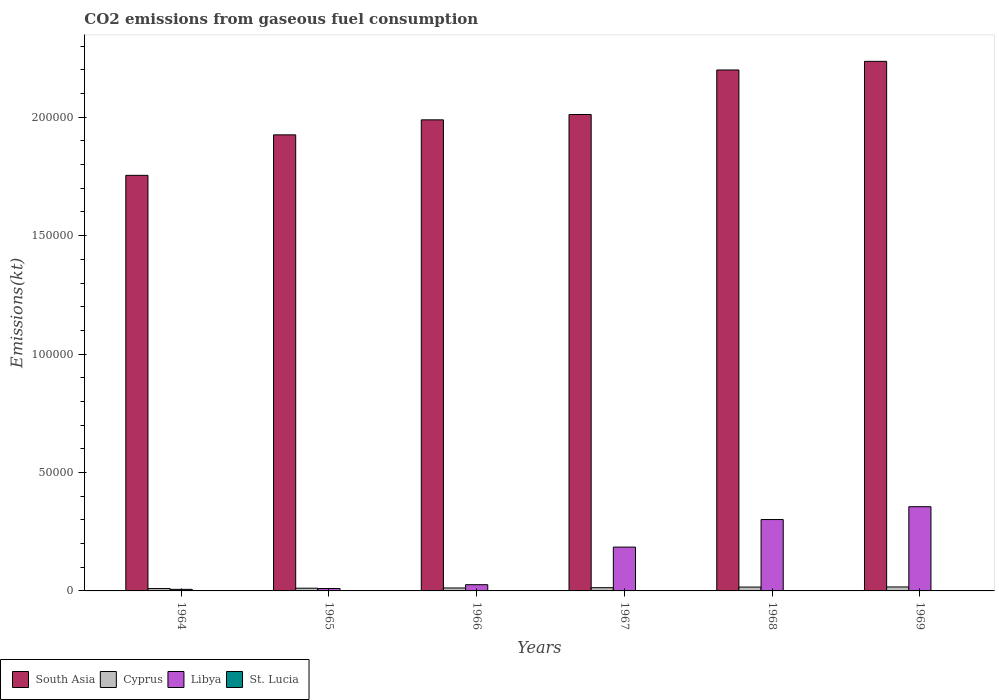How many different coloured bars are there?
Provide a succinct answer. 4. What is the label of the 2nd group of bars from the left?
Provide a short and direct response. 1965. What is the amount of CO2 emitted in Cyprus in 1968?
Keep it short and to the point. 1624.48. Across all years, what is the maximum amount of CO2 emitted in St. Lucia?
Make the answer very short. 62.34. Across all years, what is the minimum amount of CO2 emitted in Libya?
Your response must be concise. 663.73. In which year was the amount of CO2 emitted in St. Lucia maximum?
Offer a very short reply. 1969. In which year was the amount of CO2 emitted in South Asia minimum?
Provide a succinct answer. 1964. What is the total amount of CO2 emitted in Libya in the graph?
Provide a succinct answer. 8.85e+04. What is the difference between the amount of CO2 emitted in Libya in 1966 and that in 1968?
Your answer should be very brief. -2.75e+04. What is the difference between the amount of CO2 emitted in South Asia in 1968 and the amount of CO2 emitted in St. Lucia in 1969?
Your answer should be compact. 2.20e+05. What is the average amount of CO2 emitted in Cyprus per year?
Give a very brief answer. 1342.73. In the year 1969, what is the difference between the amount of CO2 emitted in Cyprus and amount of CO2 emitted in South Asia?
Give a very brief answer. -2.22e+05. What is the ratio of the amount of CO2 emitted in South Asia in 1965 to that in 1968?
Provide a succinct answer. 0.88. Is the difference between the amount of CO2 emitted in Cyprus in 1965 and 1967 greater than the difference between the amount of CO2 emitted in South Asia in 1965 and 1967?
Offer a very short reply. Yes. What is the difference between the highest and the second highest amount of CO2 emitted in Libya?
Give a very brief answer. 5412.49. What is the difference between the highest and the lowest amount of CO2 emitted in Libya?
Make the answer very short. 3.49e+04. What does the 3rd bar from the left in 1968 represents?
Ensure brevity in your answer.  Libya. What does the 2nd bar from the right in 1968 represents?
Your answer should be compact. Libya. How many years are there in the graph?
Make the answer very short. 6. Does the graph contain any zero values?
Your answer should be compact. No. Where does the legend appear in the graph?
Provide a succinct answer. Bottom left. How are the legend labels stacked?
Ensure brevity in your answer.  Horizontal. What is the title of the graph?
Ensure brevity in your answer.  CO2 emissions from gaseous fuel consumption. Does "Croatia" appear as one of the legend labels in the graph?
Your answer should be compact. No. What is the label or title of the X-axis?
Offer a very short reply. Years. What is the label or title of the Y-axis?
Your answer should be compact. Emissions(kt). What is the Emissions(kt) of South Asia in 1964?
Provide a short and direct response. 1.75e+05. What is the Emissions(kt) of Cyprus in 1964?
Make the answer very short. 1001.09. What is the Emissions(kt) in Libya in 1964?
Your answer should be compact. 663.73. What is the Emissions(kt) of St. Lucia in 1964?
Offer a very short reply. 22. What is the Emissions(kt) in South Asia in 1965?
Your answer should be very brief. 1.93e+05. What is the Emissions(kt) in Cyprus in 1965?
Offer a very short reply. 1151.44. What is the Emissions(kt) in Libya in 1965?
Make the answer very short. 1015.76. What is the Emissions(kt) of St. Lucia in 1965?
Provide a succinct answer. 25.67. What is the Emissions(kt) in South Asia in 1966?
Your answer should be compact. 1.99e+05. What is the Emissions(kt) of Cyprus in 1966?
Offer a very short reply. 1243.11. What is the Emissions(kt) of Libya in 1966?
Offer a terse response. 2629.24. What is the Emissions(kt) of St. Lucia in 1966?
Offer a terse response. 29.34. What is the Emissions(kt) of South Asia in 1967?
Keep it short and to the point. 2.01e+05. What is the Emissions(kt) in Cyprus in 1967?
Your answer should be compact. 1364.12. What is the Emissions(kt) of Libya in 1967?
Your answer should be compact. 1.85e+04. What is the Emissions(kt) in St. Lucia in 1967?
Keep it short and to the point. 33. What is the Emissions(kt) of South Asia in 1968?
Offer a terse response. 2.20e+05. What is the Emissions(kt) in Cyprus in 1968?
Provide a short and direct response. 1624.48. What is the Emissions(kt) in Libya in 1968?
Ensure brevity in your answer.  3.01e+04. What is the Emissions(kt) in St. Lucia in 1968?
Keep it short and to the point. 36.67. What is the Emissions(kt) in South Asia in 1969?
Your answer should be very brief. 2.24e+05. What is the Emissions(kt) in Cyprus in 1969?
Offer a very short reply. 1672.15. What is the Emissions(kt) in Libya in 1969?
Offer a very short reply. 3.56e+04. What is the Emissions(kt) in St. Lucia in 1969?
Provide a short and direct response. 62.34. Across all years, what is the maximum Emissions(kt) in South Asia?
Give a very brief answer. 2.24e+05. Across all years, what is the maximum Emissions(kt) in Cyprus?
Provide a succinct answer. 1672.15. Across all years, what is the maximum Emissions(kt) of Libya?
Offer a very short reply. 3.56e+04. Across all years, what is the maximum Emissions(kt) of St. Lucia?
Make the answer very short. 62.34. Across all years, what is the minimum Emissions(kt) in South Asia?
Offer a very short reply. 1.75e+05. Across all years, what is the minimum Emissions(kt) in Cyprus?
Offer a very short reply. 1001.09. Across all years, what is the minimum Emissions(kt) of Libya?
Offer a terse response. 663.73. Across all years, what is the minimum Emissions(kt) in St. Lucia?
Your answer should be very brief. 22. What is the total Emissions(kt) in South Asia in the graph?
Your answer should be compact. 1.21e+06. What is the total Emissions(kt) in Cyprus in the graph?
Provide a short and direct response. 8056.4. What is the total Emissions(kt) in Libya in the graph?
Your response must be concise. 8.85e+04. What is the total Emissions(kt) in St. Lucia in the graph?
Provide a short and direct response. 209.02. What is the difference between the Emissions(kt) of South Asia in 1964 and that in 1965?
Give a very brief answer. -1.71e+04. What is the difference between the Emissions(kt) in Cyprus in 1964 and that in 1965?
Keep it short and to the point. -150.35. What is the difference between the Emissions(kt) of Libya in 1964 and that in 1965?
Make the answer very short. -352.03. What is the difference between the Emissions(kt) of St. Lucia in 1964 and that in 1965?
Give a very brief answer. -3.67. What is the difference between the Emissions(kt) of South Asia in 1964 and that in 1966?
Give a very brief answer. -2.34e+04. What is the difference between the Emissions(kt) of Cyprus in 1964 and that in 1966?
Your response must be concise. -242.02. What is the difference between the Emissions(kt) of Libya in 1964 and that in 1966?
Keep it short and to the point. -1965.51. What is the difference between the Emissions(kt) of St. Lucia in 1964 and that in 1966?
Your answer should be very brief. -7.33. What is the difference between the Emissions(kt) of South Asia in 1964 and that in 1967?
Provide a succinct answer. -2.57e+04. What is the difference between the Emissions(kt) in Cyprus in 1964 and that in 1967?
Your answer should be very brief. -363.03. What is the difference between the Emissions(kt) in Libya in 1964 and that in 1967?
Your response must be concise. -1.78e+04. What is the difference between the Emissions(kt) of St. Lucia in 1964 and that in 1967?
Offer a very short reply. -11. What is the difference between the Emissions(kt) of South Asia in 1964 and that in 1968?
Provide a short and direct response. -4.45e+04. What is the difference between the Emissions(kt) in Cyprus in 1964 and that in 1968?
Offer a very short reply. -623.39. What is the difference between the Emissions(kt) of Libya in 1964 and that in 1968?
Offer a terse response. -2.95e+04. What is the difference between the Emissions(kt) in St. Lucia in 1964 and that in 1968?
Offer a very short reply. -14.67. What is the difference between the Emissions(kt) of South Asia in 1964 and that in 1969?
Provide a succinct answer. -4.81e+04. What is the difference between the Emissions(kt) in Cyprus in 1964 and that in 1969?
Ensure brevity in your answer.  -671.06. What is the difference between the Emissions(kt) of Libya in 1964 and that in 1969?
Make the answer very short. -3.49e+04. What is the difference between the Emissions(kt) of St. Lucia in 1964 and that in 1969?
Offer a very short reply. -40.34. What is the difference between the Emissions(kt) of South Asia in 1965 and that in 1966?
Ensure brevity in your answer.  -6335.61. What is the difference between the Emissions(kt) of Cyprus in 1965 and that in 1966?
Provide a succinct answer. -91.67. What is the difference between the Emissions(kt) of Libya in 1965 and that in 1966?
Your response must be concise. -1613.48. What is the difference between the Emissions(kt) of St. Lucia in 1965 and that in 1966?
Provide a short and direct response. -3.67. What is the difference between the Emissions(kt) in South Asia in 1965 and that in 1967?
Your answer should be compact. -8586.38. What is the difference between the Emissions(kt) in Cyprus in 1965 and that in 1967?
Your answer should be compact. -212.69. What is the difference between the Emissions(kt) in Libya in 1965 and that in 1967?
Offer a very short reply. -1.75e+04. What is the difference between the Emissions(kt) in St. Lucia in 1965 and that in 1967?
Provide a short and direct response. -7.33. What is the difference between the Emissions(kt) in South Asia in 1965 and that in 1968?
Provide a short and direct response. -2.74e+04. What is the difference between the Emissions(kt) in Cyprus in 1965 and that in 1968?
Your response must be concise. -473.04. What is the difference between the Emissions(kt) in Libya in 1965 and that in 1968?
Your answer should be compact. -2.91e+04. What is the difference between the Emissions(kt) in St. Lucia in 1965 and that in 1968?
Ensure brevity in your answer.  -11. What is the difference between the Emissions(kt) of South Asia in 1965 and that in 1969?
Ensure brevity in your answer.  -3.10e+04. What is the difference between the Emissions(kt) of Cyprus in 1965 and that in 1969?
Provide a succinct answer. -520.71. What is the difference between the Emissions(kt) in Libya in 1965 and that in 1969?
Your answer should be very brief. -3.45e+04. What is the difference between the Emissions(kt) in St. Lucia in 1965 and that in 1969?
Give a very brief answer. -36.67. What is the difference between the Emissions(kt) in South Asia in 1966 and that in 1967?
Offer a very short reply. -2250.76. What is the difference between the Emissions(kt) of Cyprus in 1966 and that in 1967?
Make the answer very short. -121.01. What is the difference between the Emissions(kt) in Libya in 1966 and that in 1967?
Offer a terse response. -1.59e+04. What is the difference between the Emissions(kt) of St. Lucia in 1966 and that in 1967?
Your response must be concise. -3.67. What is the difference between the Emissions(kt) in South Asia in 1966 and that in 1968?
Your answer should be compact. -2.11e+04. What is the difference between the Emissions(kt) of Cyprus in 1966 and that in 1968?
Offer a terse response. -381.37. What is the difference between the Emissions(kt) of Libya in 1966 and that in 1968?
Offer a terse response. -2.75e+04. What is the difference between the Emissions(kt) of St. Lucia in 1966 and that in 1968?
Make the answer very short. -7.33. What is the difference between the Emissions(kt) in South Asia in 1966 and that in 1969?
Provide a succinct answer. -2.47e+04. What is the difference between the Emissions(kt) in Cyprus in 1966 and that in 1969?
Your answer should be compact. -429.04. What is the difference between the Emissions(kt) in Libya in 1966 and that in 1969?
Give a very brief answer. -3.29e+04. What is the difference between the Emissions(kt) of St. Lucia in 1966 and that in 1969?
Your answer should be compact. -33. What is the difference between the Emissions(kt) in South Asia in 1967 and that in 1968?
Your answer should be compact. -1.88e+04. What is the difference between the Emissions(kt) in Cyprus in 1967 and that in 1968?
Your response must be concise. -260.36. What is the difference between the Emissions(kt) of Libya in 1967 and that in 1968?
Offer a very short reply. -1.16e+04. What is the difference between the Emissions(kt) in St. Lucia in 1967 and that in 1968?
Your answer should be very brief. -3.67. What is the difference between the Emissions(kt) of South Asia in 1967 and that in 1969?
Your answer should be compact. -2.24e+04. What is the difference between the Emissions(kt) in Cyprus in 1967 and that in 1969?
Your answer should be compact. -308.03. What is the difference between the Emissions(kt) in Libya in 1967 and that in 1969?
Your answer should be very brief. -1.70e+04. What is the difference between the Emissions(kt) in St. Lucia in 1967 and that in 1969?
Keep it short and to the point. -29.34. What is the difference between the Emissions(kt) of South Asia in 1968 and that in 1969?
Your answer should be very brief. -3638.42. What is the difference between the Emissions(kt) of Cyprus in 1968 and that in 1969?
Provide a short and direct response. -47.67. What is the difference between the Emissions(kt) of Libya in 1968 and that in 1969?
Keep it short and to the point. -5412.49. What is the difference between the Emissions(kt) in St. Lucia in 1968 and that in 1969?
Keep it short and to the point. -25.67. What is the difference between the Emissions(kt) of South Asia in 1964 and the Emissions(kt) of Cyprus in 1965?
Keep it short and to the point. 1.74e+05. What is the difference between the Emissions(kt) in South Asia in 1964 and the Emissions(kt) in Libya in 1965?
Keep it short and to the point. 1.74e+05. What is the difference between the Emissions(kt) of South Asia in 1964 and the Emissions(kt) of St. Lucia in 1965?
Your response must be concise. 1.75e+05. What is the difference between the Emissions(kt) in Cyprus in 1964 and the Emissions(kt) in Libya in 1965?
Provide a succinct answer. -14.67. What is the difference between the Emissions(kt) in Cyprus in 1964 and the Emissions(kt) in St. Lucia in 1965?
Your answer should be compact. 975.42. What is the difference between the Emissions(kt) in Libya in 1964 and the Emissions(kt) in St. Lucia in 1965?
Provide a succinct answer. 638.06. What is the difference between the Emissions(kt) of South Asia in 1964 and the Emissions(kt) of Cyprus in 1966?
Provide a short and direct response. 1.74e+05. What is the difference between the Emissions(kt) in South Asia in 1964 and the Emissions(kt) in Libya in 1966?
Give a very brief answer. 1.73e+05. What is the difference between the Emissions(kt) in South Asia in 1964 and the Emissions(kt) in St. Lucia in 1966?
Give a very brief answer. 1.75e+05. What is the difference between the Emissions(kt) in Cyprus in 1964 and the Emissions(kt) in Libya in 1966?
Make the answer very short. -1628.15. What is the difference between the Emissions(kt) in Cyprus in 1964 and the Emissions(kt) in St. Lucia in 1966?
Offer a terse response. 971.75. What is the difference between the Emissions(kt) in Libya in 1964 and the Emissions(kt) in St. Lucia in 1966?
Provide a short and direct response. 634.39. What is the difference between the Emissions(kt) of South Asia in 1964 and the Emissions(kt) of Cyprus in 1967?
Make the answer very short. 1.74e+05. What is the difference between the Emissions(kt) in South Asia in 1964 and the Emissions(kt) in Libya in 1967?
Keep it short and to the point. 1.57e+05. What is the difference between the Emissions(kt) of South Asia in 1964 and the Emissions(kt) of St. Lucia in 1967?
Make the answer very short. 1.75e+05. What is the difference between the Emissions(kt) of Cyprus in 1964 and the Emissions(kt) of Libya in 1967?
Make the answer very short. -1.75e+04. What is the difference between the Emissions(kt) of Cyprus in 1964 and the Emissions(kt) of St. Lucia in 1967?
Provide a short and direct response. 968.09. What is the difference between the Emissions(kt) in Libya in 1964 and the Emissions(kt) in St. Lucia in 1967?
Ensure brevity in your answer.  630.72. What is the difference between the Emissions(kt) of South Asia in 1964 and the Emissions(kt) of Cyprus in 1968?
Your answer should be compact. 1.74e+05. What is the difference between the Emissions(kt) in South Asia in 1964 and the Emissions(kt) in Libya in 1968?
Keep it short and to the point. 1.45e+05. What is the difference between the Emissions(kt) of South Asia in 1964 and the Emissions(kt) of St. Lucia in 1968?
Ensure brevity in your answer.  1.75e+05. What is the difference between the Emissions(kt) in Cyprus in 1964 and the Emissions(kt) in Libya in 1968?
Provide a succinct answer. -2.91e+04. What is the difference between the Emissions(kt) of Cyprus in 1964 and the Emissions(kt) of St. Lucia in 1968?
Your answer should be very brief. 964.42. What is the difference between the Emissions(kt) in Libya in 1964 and the Emissions(kt) in St. Lucia in 1968?
Your answer should be compact. 627.06. What is the difference between the Emissions(kt) of South Asia in 1964 and the Emissions(kt) of Cyprus in 1969?
Keep it short and to the point. 1.74e+05. What is the difference between the Emissions(kt) in South Asia in 1964 and the Emissions(kt) in Libya in 1969?
Provide a short and direct response. 1.40e+05. What is the difference between the Emissions(kt) of South Asia in 1964 and the Emissions(kt) of St. Lucia in 1969?
Your answer should be very brief. 1.75e+05. What is the difference between the Emissions(kt) in Cyprus in 1964 and the Emissions(kt) in Libya in 1969?
Provide a succinct answer. -3.46e+04. What is the difference between the Emissions(kt) in Cyprus in 1964 and the Emissions(kt) in St. Lucia in 1969?
Make the answer very short. 938.75. What is the difference between the Emissions(kt) in Libya in 1964 and the Emissions(kt) in St. Lucia in 1969?
Your answer should be very brief. 601.39. What is the difference between the Emissions(kt) in South Asia in 1965 and the Emissions(kt) in Cyprus in 1966?
Keep it short and to the point. 1.91e+05. What is the difference between the Emissions(kt) in South Asia in 1965 and the Emissions(kt) in Libya in 1966?
Your response must be concise. 1.90e+05. What is the difference between the Emissions(kt) of South Asia in 1965 and the Emissions(kt) of St. Lucia in 1966?
Your answer should be very brief. 1.93e+05. What is the difference between the Emissions(kt) in Cyprus in 1965 and the Emissions(kt) in Libya in 1966?
Give a very brief answer. -1477.8. What is the difference between the Emissions(kt) in Cyprus in 1965 and the Emissions(kt) in St. Lucia in 1966?
Your answer should be compact. 1122.1. What is the difference between the Emissions(kt) of Libya in 1965 and the Emissions(kt) of St. Lucia in 1966?
Provide a short and direct response. 986.42. What is the difference between the Emissions(kt) in South Asia in 1965 and the Emissions(kt) in Cyprus in 1967?
Give a very brief answer. 1.91e+05. What is the difference between the Emissions(kt) in South Asia in 1965 and the Emissions(kt) in Libya in 1967?
Your response must be concise. 1.74e+05. What is the difference between the Emissions(kt) in South Asia in 1965 and the Emissions(kt) in St. Lucia in 1967?
Give a very brief answer. 1.93e+05. What is the difference between the Emissions(kt) in Cyprus in 1965 and the Emissions(kt) in Libya in 1967?
Make the answer very short. -1.74e+04. What is the difference between the Emissions(kt) in Cyprus in 1965 and the Emissions(kt) in St. Lucia in 1967?
Offer a terse response. 1118.43. What is the difference between the Emissions(kt) of Libya in 1965 and the Emissions(kt) of St. Lucia in 1967?
Your answer should be compact. 982.76. What is the difference between the Emissions(kt) of South Asia in 1965 and the Emissions(kt) of Cyprus in 1968?
Offer a very short reply. 1.91e+05. What is the difference between the Emissions(kt) in South Asia in 1965 and the Emissions(kt) in Libya in 1968?
Give a very brief answer. 1.62e+05. What is the difference between the Emissions(kt) of South Asia in 1965 and the Emissions(kt) of St. Lucia in 1968?
Offer a terse response. 1.93e+05. What is the difference between the Emissions(kt) of Cyprus in 1965 and the Emissions(kt) of Libya in 1968?
Ensure brevity in your answer.  -2.90e+04. What is the difference between the Emissions(kt) of Cyprus in 1965 and the Emissions(kt) of St. Lucia in 1968?
Provide a short and direct response. 1114.77. What is the difference between the Emissions(kt) of Libya in 1965 and the Emissions(kt) of St. Lucia in 1968?
Keep it short and to the point. 979.09. What is the difference between the Emissions(kt) in South Asia in 1965 and the Emissions(kt) in Cyprus in 1969?
Your answer should be very brief. 1.91e+05. What is the difference between the Emissions(kt) of South Asia in 1965 and the Emissions(kt) of Libya in 1969?
Provide a succinct answer. 1.57e+05. What is the difference between the Emissions(kt) in South Asia in 1965 and the Emissions(kt) in St. Lucia in 1969?
Your answer should be compact. 1.92e+05. What is the difference between the Emissions(kt) of Cyprus in 1965 and the Emissions(kt) of Libya in 1969?
Offer a terse response. -3.44e+04. What is the difference between the Emissions(kt) of Cyprus in 1965 and the Emissions(kt) of St. Lucia in 1969?
Ensure brevity in your answer.  1089.1. What is the difference between the Emissions(kt) of Libya in 1965 and the Emissions(kt) of St. Lucia in 1969?
Provide a short and direct response. 953.42. What is the difference between the Emissions(kt) of South Asia in 1966 and the Emissions(kt) of Cyprus in 1967?
Provide a short and direct response. 1.98e+05. What is the difference between the Emissions(kt) of South Asia in 1966 and the Emissions(kt) of Libya in 1967?
Provide a short and direct response. 1.80e+05. What is the difference between the Emissions(kt) of South Asia in 1966 and the Emissions(kt) of St. Lucia in 1967?
Give a very brief answer. 1.99e+05. What is the difference between the Emissions(kt) in Cyprus in 1966 and the Emissions(kt) in Libya in 1967?
Your response must be concise. -1.73e+04. What is the difference between the Emissions(kt) of Cyprus in 1966 and the Emissions(kt) of St. Lucia in 1967?
Give a very brief answer. 1210.11. What is the difference between the Emissions(kt) of Libya in 1966 and the Emissions(kt) of St. Lucia in 1967?
Keep it short and to the point. 2596.24. What is the difference between the Emissions(kt) of South Asia in 1966 and the Emissions(kt) of Cyprus in 1968?
Your response must be concise. 1.97e+05. What is the difference between the Emissions(kt) of South Asia in 1966 and the Emissions(kt) of Libya in 1968?
Your answer should be compact. 1.69e+05. What is the difference between the Emissions(kt) in South Asia in 1966 and the Emissions(kt) in St. Lucia in 1968?
Your answer should be very brief. 1.99e+05. What is the difference between the Emissions(kt) in Cyprus in 1966 and the Emissions(kt) in Libya in 1968?
Offer a terse response. -2.89e+04. What is the difference between the Emissions(kt) of Cyprus in 1966 and the Emissions(kt) of St. Lucia in 1968?
Ensure brevity in your answer.  1206.44. What is the difference between the Emissions(kt) in Libya in 1966 and the Emissions(kt) in St. Lucia in 1968?
Provide a succinct answer. 2592.57. What is the difference between the Emissions(kt) in South Asia in 1966 and the Emissions(kt) in Cyprus in 1969?
Provide a short and direct response. 1.97e+05. What is the difference between the Emissions(kt) in South Asia in 1966 and the Emissions(kt) in Libya in 1969?
Make the answer very short. 1.63e+05. What is the difference between the Emissions(kt) in South Asia in 1966 and the Emissions(kt) in St. Lucia in 1969?
Offer a very short reply. 1.99e+05. What is the difference between the Emissions(kt) in Cyprus in 1966 and the Emissions(kt) in Libya in 1969?
Make the answer very short. -3.43e+04. What is the difference between the Emissions(kt) in Cyprus in 1966 and the Emissions(kt) in St. Lucia in 1969?
Offer a very short reply. 1180.77. What is the difference between the Emissions(kt) in Libya in 1966 and the Emissions(kt) in St. Lucia in 1969?
Provide a short and direct response. 2566.9. What is the difference between the Emissions(kt) of South Asia in 1967 and the Emissions(kt) of Cyprus in 1968?
Keep it short and to the point. 2.00e+05. What is the difference between the Emissions(kt) of South Asia in 1967 and the Emissions(kt) of Libya in 1968?
Give a very brief answer. 1.71e+05. What is the difference between the Emissions(kt) in South Asia in 1967 and the Emissions(kt) in St. Lucia in 1968?
Your answer should be very brief. 2.01e+05. What is the difference between the Emissions(kt) of Cyprus in 1967 and the Emissions(kt) of Libya in 1968?
Your answer should be very brief. -2.88e+04. What is the difference between the Emissions(kt) in Cyprus in 1967 and the Emissions(kt) in St. Lucia in 1968?
Provide a succinct answer. 1327.45. What is the difference between the Emissions(kt) of Libya in 1967 and the Emissions(kt) of St. Lucia in 1968?
Your response must be concise. 1.85e+04. What is the difference between the Emissions(kt) in South Asia in 1967 and the Emissions(kt) in Cyprus in 1969?
Provide a short and direct response. 1.99e+05. What is the difference between the Emissions(kt) in South Asia in 1967 and the Emissions(kt) in Libya in 1969?
Ensure brevity in your answer.  1.66e+05. What is the difference between the Emissions(kt) of South Asia in 1967 and the Emissions(kt) of St. Lucia in 1969?
Your response must be concise. 2.01e+05. What is the difference between the Emissions(kt) of Cyprus in 1967 and the Emissions(kt) of Libya in 1969?
Offer a terse response. -3.42e+04. What is the difference between the Emissions(kt) of Cyprus in 1967 and the Emissions(kt) of St. Lucia in 1969?
Your answer should be compact. 1301.79. What is the difference between the Emissions(kt) of Libya in 1967 and the Emissions(kt) of St. Lucia in 1969?
Your response must be concise. 1.84e+04. What is the difference between the Emissions(kt) in South Asia in 1968 and the Emissions(kt) in Cyprus in 1969?
Provide a succinct answer. 2.18e+05. What is the difference between the Emissions(kt) in South Asia in 1968 and the Emissions(kt) in Libya in 1969?
Your answer should be compact. 1.84e+05. What is the difference between the Emissions(kt) of South Asia in 1968 and the Emissions(kt) of St. Lucia in 1969?
Give a very brief answer. 2.20e+05. What is the difference between the Emissions(kt) of Cyprus in 1968 and the Emissions(kt) of Libya in 1969?
Provide a succinct answer. -3.39e+04. What is the difference between the Emissions(kt) in Cyprus in 1968 and the Emissions(kt) in St. Lucia in 1969?
Offer a terse response. 1562.14. What is the difference between the Emissions(kt) of Libya in 1968 and the Emissions(kt) of St. Lucia in 1969?
Your response must be concise. 3.01e+04. What is the average Emissions(kt) of South Asia per year?
Your answer should be compact. 2.02e+05. What is the average Emissions(kt) of Cyprus per year?
Give a very brief answer. 1342.73. What is the average Emissions(kt) of Libya per year?
Your response must be concise. 1.48e+04. What is the average Emissions(kt) in St. Lucia per year?
Provide a succinct answer. 34.84. In the year 1964, what is the difference between the Emissions(kt) of South Asia and Emissions(kt) of Cyprus?
Provide a short and direct response. 1.74e+05. In the year 1964, what is the difference between the Emissions(kt) of South Asia and Emissions(kt) of Libya?
Keep it short and to the point. 1.75e+05. In the year 1964, what is the difference between the Emissions(kt) in South Asia and Emissions(kt) in St. Lucia?
Offer a terse response. 1.75e+05. In the year 1964, what is the difference between the Emissions(kt) of Cyprus and Emissions(kt) of Libya?
Offer a very short reply. 337.36. In the year 1964, what is the difference between the Emissions(kt) in Cyprus and Emissions(kt) in St. Lucia?
Keep it short and to the point. 979.09. In the year 1964, what is the difference between the Emissions(kt) of Libya and Emissions(kt) of St. Lucia?
Your response must be concise. 641.73. In the year 1965, what is the difference between the Emissions(kt) in South Asia and Emissions(kt) in Cyprus?
Your answer should be compact. 1.91e+05. In the year 1965, what is the difference between the Emissions(kt) in South Asia and Emissions(kt) in Libya?
Your response must be concise. 1.92e+05. In the year 1965, what is the difference between the Emissions(kt) in South Asia and Emissions(kt) in St. Lucia?
Give a very brief answer. 1.93e+05. In the year 1965, what is the difference between the Emissions(kt) of Cyprus and Emissions(kt) of Libya?
Offer a very short reply. 135.68. In the year 1965, what is the difference between the Emissions(kt) in Cyprus and Emissions(kt) in St. Lucia?
Your answer should be very brief. 1125.77. In the year 1965, what is the difference between the Emissions(kt) of Libya and Emissions(kt) of St. Lucia?
Your answer should be compact. 990.09. In the year 1966, what is the difference between the Emissions(kt) in South Asia and Emissions(kt) in Cyprus?
Provide a succinct answer. 1.98e+05. In the year 1966, what is the difference between the Emissions(kt) of South Asia and Emissions(kt) of Libya?
Offer a very short reply. 1.96e+05. In the year 1966, what is the difference between the Emissions(kt) of South Asia and Emissions(kt) of St. Lucia?
Your answer should be compact. 1.99e+05. In the year 1966, what is the difference between the Emissions(kt) in Cyprus and Emissions(kt) in Libya?
Keep it short and to the point. -1386.13. In the year 1966, what is the difference between the Emissions(kt) in Cyprus and Emissions(kt) in St. Lucia?
Keep it short and to the point. 1213.78. In the year 1966, what is the difference between the Emissions(kt) in Libya and Emissions(kt) in St. Lucia?
Give a very brief answer. 2599.9. In the year 1967, what is the difference between the Emissions(kt) in South Asia and Emissions(kt) in Cyprus?
Provide a short and direct response. 2.00e+05. In the year 1967, what is the difference between the Emissions(kt) of South Asia and Emissions(kt) of Libya?
Offer a very short reply. 1.83e+05. In the year 1967, what is the difference between the Emissions(kt) of South Asia and Emissions(kt) of St. Lucia?
Your response must be concise. 2.01e+05. In the year 1967, what is the difference between the Emissions(kt) in Cyprus and Emissions(kt) in Libya?
Your response must be concise. -1.71e+04. In the year 1967, what is the difference between the Emissions(kt) in Cyprus and Emissions(kt) in St. Lucia?
Give a very brief answer. 1331.12. In the year 1967, what is the difference between the Emissions(kt) in Libya and Emissions(kt) in St. Lucia?
Your answer should be compact. 1.85e+04. In the year 1968, what is the difference between the Emissions(kt) of South Asia and Emissions(kt) of Cyprus?
Provide a short and direct response. 2.18e+05. In the year 1968, what is the difference between the Emissions(kt) in South Asia and Emissions(kt) in Libya?
Offer a very short reply. 1.90e+05. In the year 1968, what is the difference between the Emissions(kt) in South Asia and Emissions(kt) in St. Lucia?
Provide a short and direct response. 2.20e+05. In the year 1968, what is the difference between the Emissions(kt) in Cyprus and Emissions(kt) in Libya?
Your answer should be compact. -2.85e+04. In the year 1968, what is the difference between the Emissions(kt) of Cyprus and Emissions(kt) of St. Lucia?
Your answer should be very brief. 1587.81. In the year 1968, what is the difference between the Emissions(kt) in Libya and Emissions(kt) in St. Lucia?
Ensure brevity in your answer.  3.01e+04. In the year 1969, what is the difference between the Emissions(kt) in South Asia and Emissions(kt) in Cyprus?
Your answer should be very brief. 2.22e+05. In the year 1969, what is the difference between the Emissions(kt) in South Asia and Emissions(kt) in Libya?
Ensure brevity in your answer.  1.88e+05. In the year 1969, what is the difference between the Emissions(kt) of South Asia and Emissions(kt) of St. Lucia?
Your answer should be very brief. 2.24e+05. In the year 1969, what is the difference between the Emissions(kt) in Cyprus and Emissions(kt) in Libya?
Provide a short and direct response. -3.39e+04. In the year 1969, what is the difference between the Emissions(kt) of Cyprus and Emissions(kt) of St. Lucia?
Give a very brief answer. 1609.81. In the year 1969, what is the difference between the Emissions(kt) of Libya and Emissions(kt) of St. Lucia?
Offer a terse response. 3.55e+04. What is the ratio of the Emissions(kt) in South Asia in 1964 to that in 1965?
Ensure brevity in your answer.  0.91. What is the ratio of the Emissions(kt) in Cyprus in 1964 to that in 1965?
Provide a short and direct response. 0.87. What is the ratio of the Emissions(kt) in Libya in 1964 to that in 1965?
Make the answer very short. 0.65. What is the ratio of the Emissions(kt) in South Asia in 1964 to that in 1966?
Your answer should be compact. 0.88. What is the ratio of the Emissions(kt) in Cyprus in 1964 to that in 1966?
Keep it short and to the point. 0.81. What is the ratio of the Emissions(kt) of Libya in 1964 to that in 1966?
Your answer should be very brief. 0.25. What is the ratio of the Emissions(kt) of South Asia in 1964 to that in 1967?
Ensure brevity in your answer.  0.87. What is the ratio of the Emissions(kt) of Cyprus in 1964 to that in 1967?
Ensure brevity in your answer.  0.73. What is the ratio of the Emissions(kt) of Libya in 1964 to that in 1967?
Give a very brief answer. 0.04. What is the ratio of the Emissions(kt) in St. Lucia in 1964 to that in 1967?
Your response must be concise. 0.67. What is the ratio of the Emissions(kt) in South Asia in 1964 to that in 1968?
Keep it short and to the point. 0.8. What is the ratio of the Emissions(kt) in Cyprus in 1964 to that in 1968?
Your answer should be compact. 0.62. What is the ratio of the Emissions(kt) of Libya in 1964 to that in 1968?
Provide a short and direct response. 0.02. What is the ratio of the Emissions(kt) of St. Lucia in 1964 to that in 1968?
Offer a terse response. 0.6. What is the ratio of the Emissions(kt) in South Asia in 1964 to that in 1969?
Offer a very short reply. 0.78. What is the ratio of the Emissions(kt) in Cyprus in 1964 to that in 1969?
Make the answer very short. 0.6. What is the ratio of the Emissions(kt) in Libya in 1964 to that in 1969?
Provide a succinct answer. 0.02. What is the ratio of the Emissions(kt) in St. Lucia in 1964 to that in 1969?
Make the answer very short. 0.35. What is the ratio of the Emissions(kt) in South Asia in 1965 to that in 1966?
Your answer should be compact. 0.97. What is the ratio of the Emissions(kt) of Cyprus in 1965 to that in 1966?
Provide a succinct answer. 0.93. What is the ratio of the Emissions(kt) of Libya in 1965 to that in 1966?
Ensure brevity in your answer.  0.39. What is the ratio of the Emissions(kt) in St. Lucia in 1965 to that in 1966?
Your answer should be very brief. 0.88. What is the ratio of the Emissions(kt) in South Asia in 1965 to that in 1967?
Give a very brief answer. 0.96. What is the ratio of the Emissions(kt) of Cyprus in 1965 to that in 1967?
Offer a terse response. 0.84. What is the ratio of the Emissions(kt) of Libya in 1965 to that in 1967?
Keep it short and to the point. 0.05. What is the ratio of the Emissions(kt) in South Asia in 1965 to that in 1968?
Provide a short and direct response. 0.88. What is the ratio of the Emissions(kt) in Cyprus in 1965 to that in 1968?
Your answer should be very brief. 0.71. What is the ratio of the Emissions(kt) in Libya in 1965 to that in 1968?
Offer a terse response. 0.03. What is the ratio of the Emissions(kt) of South Asia in 1965 to that in 1969?
Provide a short and direct response. 0.86. What is the ratio of the Emissions(kt) in Cyprus in 1965 to that in 1969?
Your answer should be compact. 0.69. What is the ratio of the Emissions(kt) of Libya in 1965 to that in 1969?
Your answer should be very brief. 0.03. What is the ratio of the Emissions(kt) in St. Lucia in 1965 to that in 1969?
Your answer should be compact. 0.41. What is the ratio of the Emissions(kt) of South Asia in 1966 to that in 1967?
Provide a short and direct response. 0.99. What is the ratio of the Emissions(kt) of Cyprus in 1966 to that in 1967?
Ensure brevity in your answer.  0.91. What is the ratio of the Emissions(kt) of Libya in 1966 to that in 1967?
Provide a succinct answer. 0.14. What is the ratio of the Emissions(kt) of St. Lucia in 1966 to that in 1967?
Offer a very short reply. 0.89. What is the ratio of the Emissions(kt) in South Asia in 1966 to that in 1968?
Offer a very short reply. 0.9. What is the ratio of the Emissions(kt) in Cyprus in 1966 to that in 1968?
Your answer should be compact. 0.77. What is the ratio of the Emissions(kt) of Libya in 1966 to that in 1968?
Keep it short and to the point. 0.09. What is the ratio of the Emissions(kt) of South Asia in 1966 to that in 1969?
Keep it short and to the point. 0.89. What is the ratio of the Emissions(kt) of Cyprus in 1966 to that in 1969?
Offer a terse response. 0.74. What is the ratio of the Emissions(kt) of Libya in 1966 to that in 1969?
Your response must be concise. 0.07. What is the ratio of the Emissions(kt) in St. Lucia in 1966 to that in 1969?
Your answer should be compact. 0.47. What is the ratio of the Emissions(kt) of South Asia in 1967 to that in 1968?
Offer a very short reply. 0.91. What is the ratio of the Emissions(kt) in Cyprus in 1967 to that in 1968?
Ensure brevity in your answer.  0.84. What is the ratio of the Emissions(kt) of Libya in 1967 to that in 1968?
Make the answer very short. 0.61. What is the ratio of the Emissions(kt) of St. Lucia in 1967 to that in 1968?
Your response must be concise. 0.9. What is the ratio of the Emissions(kt) in South Asia in 1967 to that in 1969?
Your answer should be compact. 0.9. What is the ratio of the Emissions(kt) in Cyprus in 1967 to that in 1969?
Your answer should be very brief. 0.82. What is the ratio of the Emissions(kt) in Libya in 1967 to that in 1969?
Your answer should be very brief. 0.52. What is the ratio of the Emissions(kt) of St. Lucia in 1967 to that in 1969?
Your answer should be compact. 0.53. What is the ratio of the Emissions(kt) in South Asia in 1968 to that in 1969?
Offer a terse response. 0.98. What is the ratio of the Emissions(kt) in Cyprus in 1968 to that in 1969?
Your answer should be compact. 0.97. What is the ratio of the Emissions(kt) of Libya in 1968 to that in 1969?
Your answer should be compact. 0.85. What is the ratio of the Emissions(kt) of St. Lucia in 1968 to that in 1969?
Ensure brevity in your answer.  0.59. What is the difference between the highest and the second highest Emissions(kt) in South Asia?
Your answer should be very brief. 3638.42. What is the difference between the highest and the second highest Emissions(kt) in Cyprus?
Give a very brief answer. 47.67. What is the difference between the highest and the second highest Emissions(kt) of Libya?
Give a very brief answer. 5412.49. What is the difference between the highest and the second highest Emissions(kt) in St. Lucia?
Your answer should be very brief. 25.67. What is the difference between the highest and the lowest Emissions(kt) of South Asia?
Provide a short and direct response. 4.81e+04. What is the difference between the highest and the lowest Emissions(kt) in Cyprus?
Ensure brevity in your answer.  671.06. What is the difference between the highest and the lowest Emissions(kt) of Libya?
Provide a short and direct response. 3.49e+04. What is the difference between the highest and the lowest Emissions(kt) of St. Lucia?
Give a very brief answer. 40.34. 